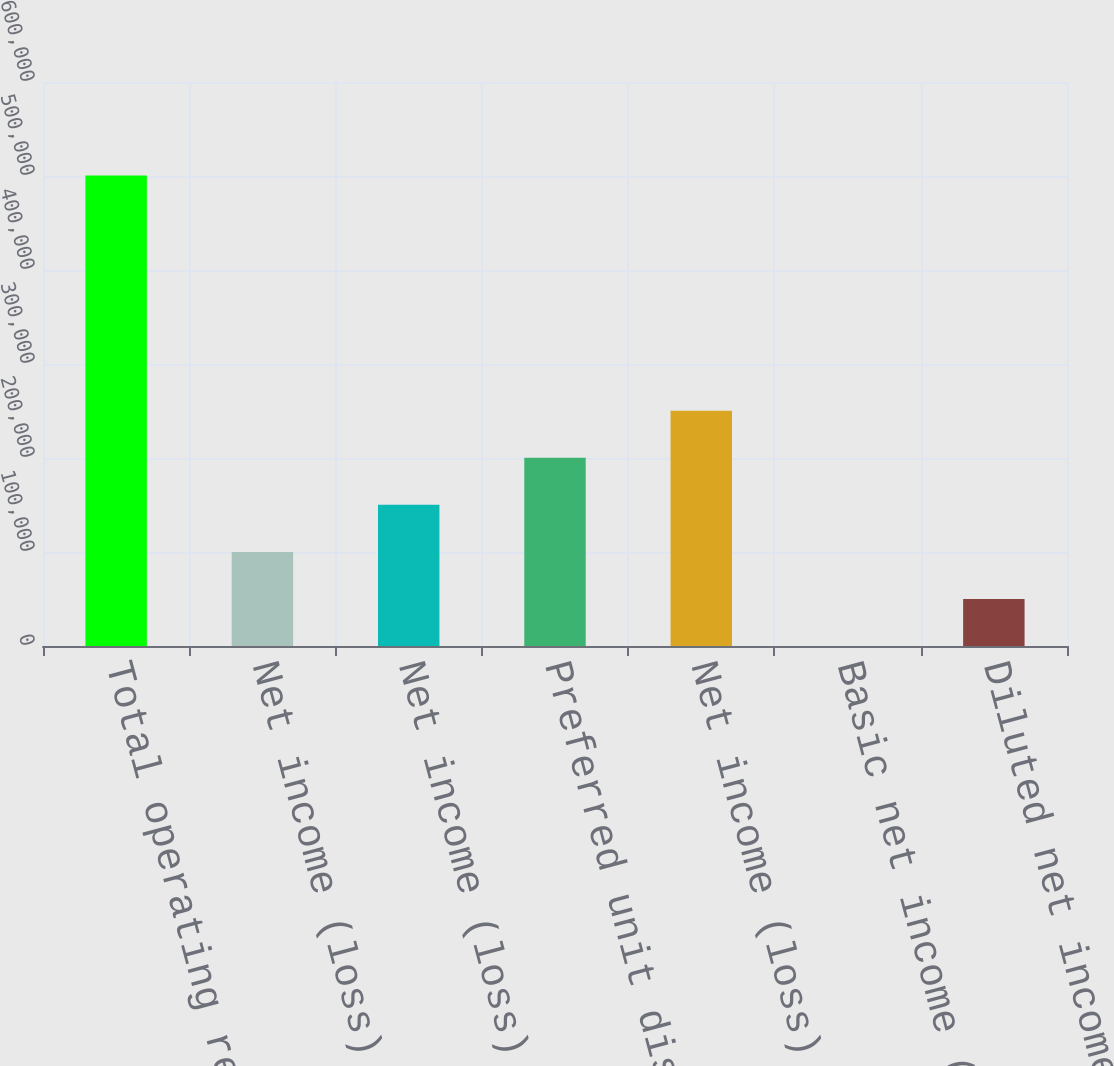Convert chart. <chart><loc_0><loc_0><loc_500><loc_500><bar_chart><fcel>Total operating revenues<fcel>Net income (loss)<fcel>Net income (loss) attributable<fcel>Preferred unit distributions<fcel>Net income (loss) available to<fcel>Basic net income (loss) per<fcel>Diluted net income (loss) per<nl><fcel>500443<fcel>100089<fcel>150133<fcel>200177<fcel>250222<fcel>0.28<fcel>50044.6<nl></chart> 